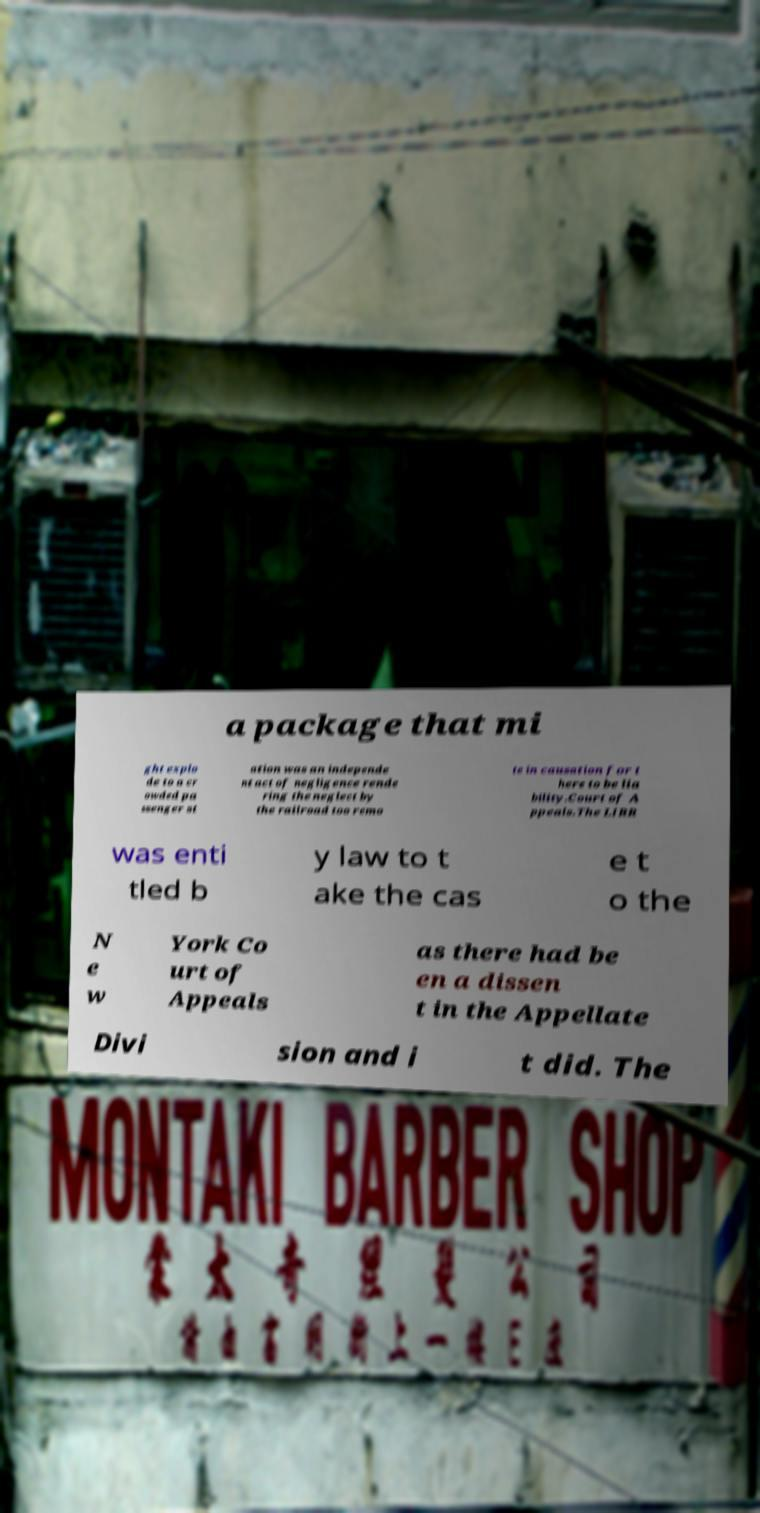Can you read and provide the text displayed in the image?This photo seems to have some interesting text. Can you extract and type it out for me? a package that mi ght explo de to a cr owded pa ssenger st ation was an independe nt act of negligence rende ring the neglect by the railroad too remo te in causation for t here to be lia bility.Court of A ppeals.The LIRR was enti tled b y law to t ake the cas e t o the N e w York Co urt of Appeals as there had be en a dissen t in the Appellate Divi sion and i t did. The 